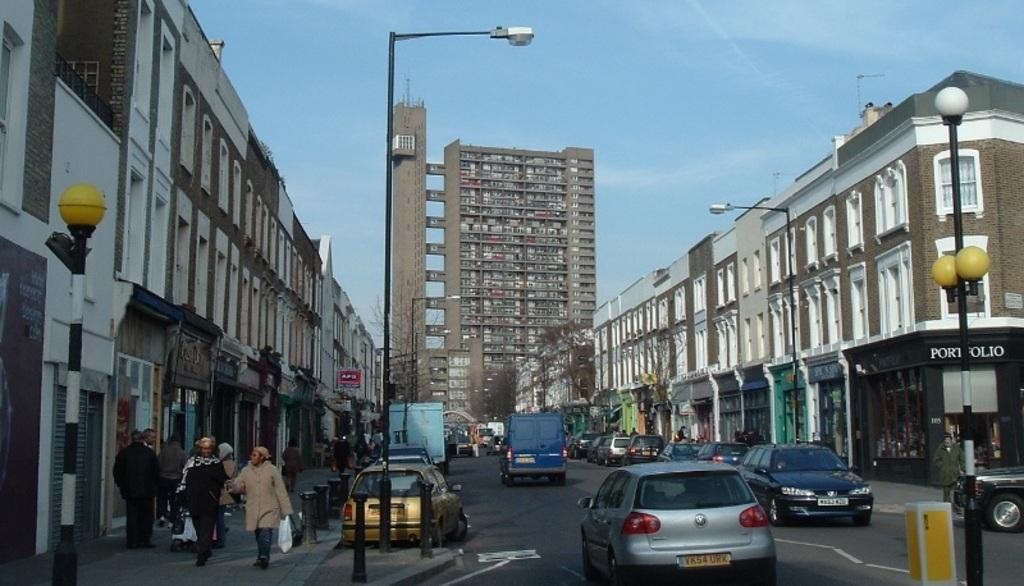What can be seen on the road in the image? There are vehicles on the road in the image. What type of illumination is present in the image? There are lights in the image. What structures are supporting the lights? There are poles in the image. Can you identify any living beings in the image? Yes, there are people visible in the image. What type of man-made structures can be seen in the image? There are buildings in the image. What is the purpose of the board in the image? The purpose of the board in the image is not clear from the facts provided. What type of vegetation is present in the image? There are trees in the image. What is visible in the background of the image? The sky is visible in the background of the image. What type of sand can be seen on the board in the image? There is no sand present in the image, and the board's purpose is not clear from the facts provided. How many zippers can be seen on the people in the image? There is no mention of zippers or clothing in the image, so it is not possible to determine the number of zippers present. 